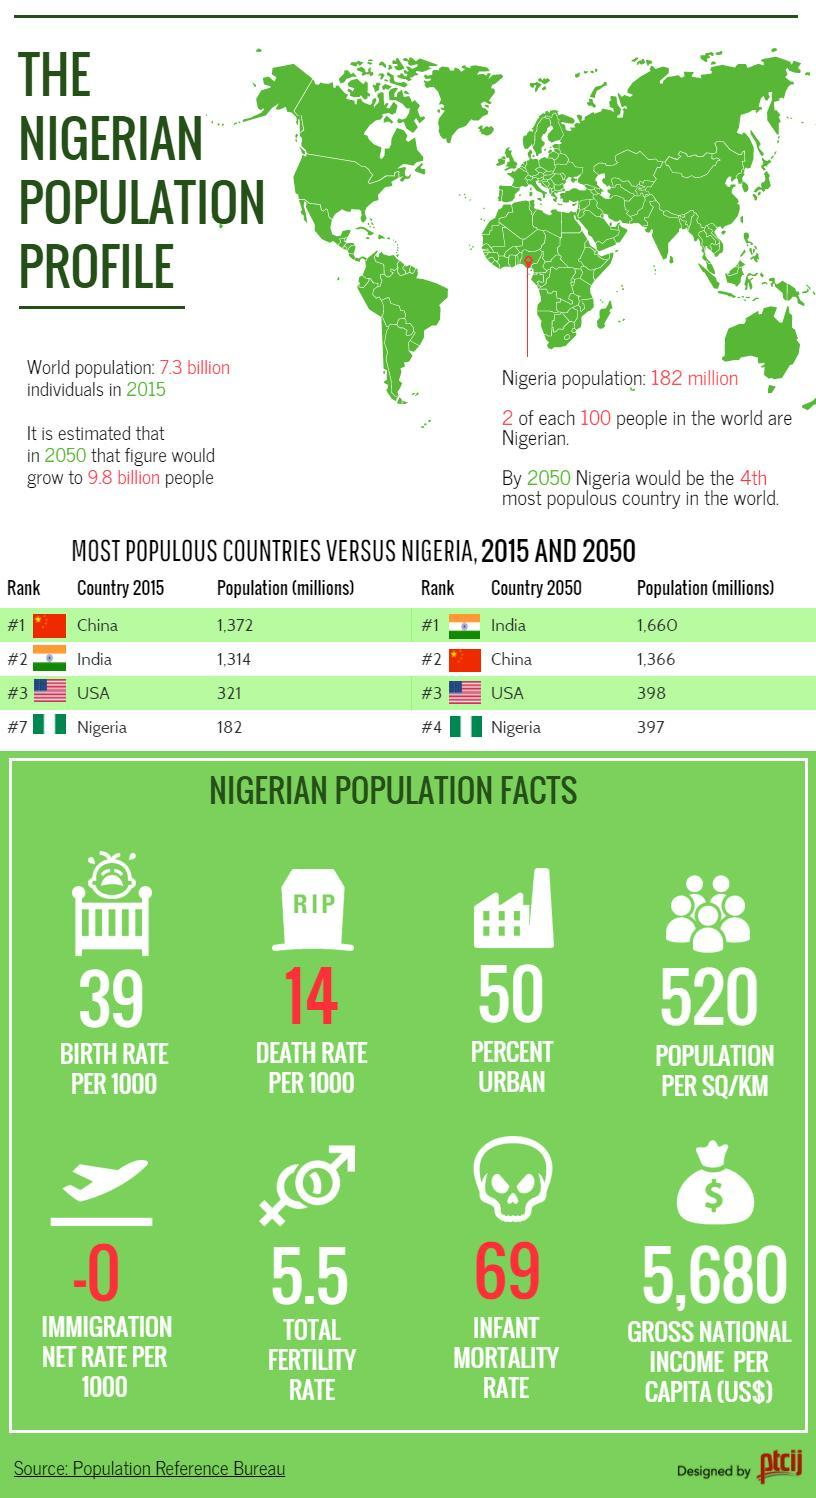What is the infant mortality rate in Nigeria?
Answer the question with a short phrase. 69 What is the population per sq/km? 520 What percent of Nigeria is urban? 50 What is the gross national income per capita (in US dollars) of Nigeria? 5,680 What is the total fertility rate of Nigeria? 5.5 What is the death rate per 1000 in Nigeria? 14 Which country is expected to surpass China in terms of population by the year 2050? India What is the estimated population (in millions) of Nigeria in the year 2050? 397 What is the birth rate per 1000 in Nigeria? 39 How much is the US population (in millions) estimated to be in 2050? 398 